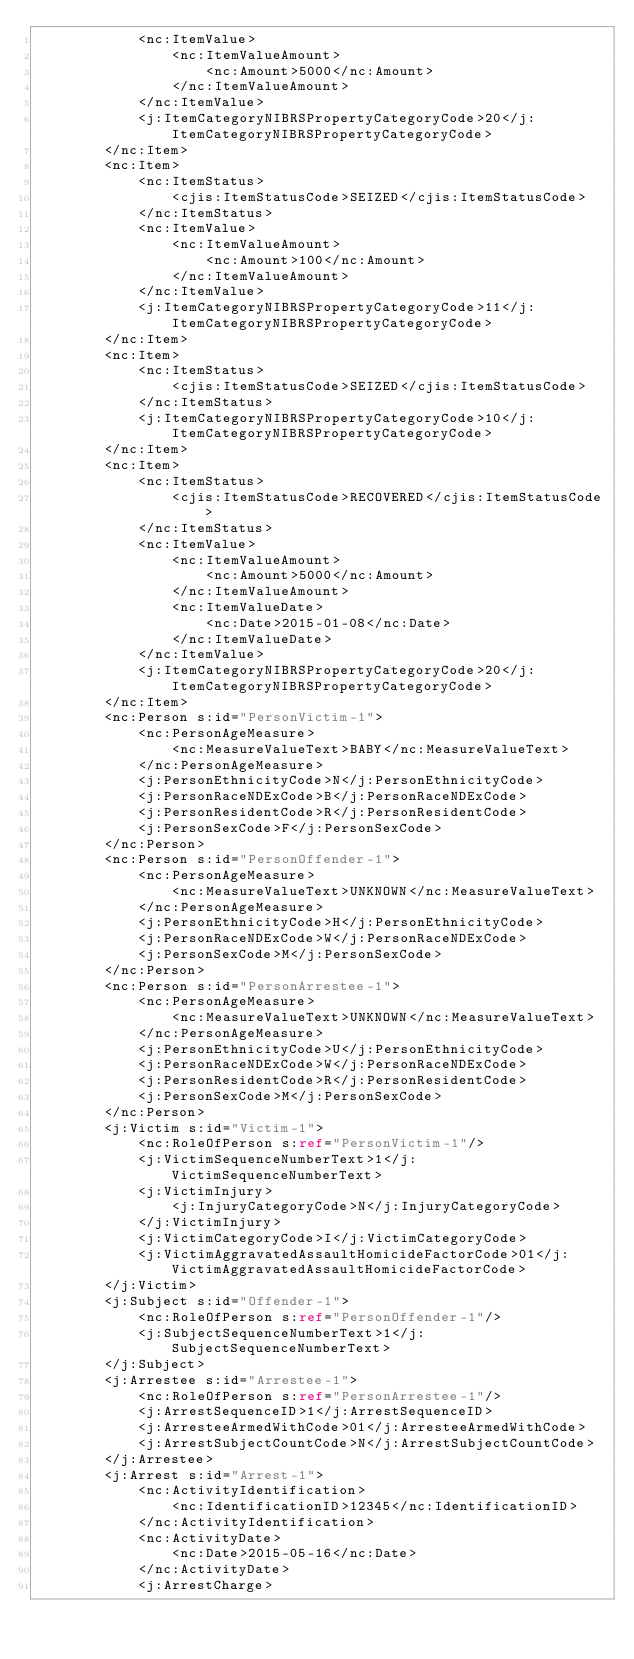Convert code to text. <code><loc_0><loc_0><loc_500><loc_500><_XML_>            <nc:ItemValue>
                <nc:ItemValueAmount>
                    <nc:Amount>5000</nc:Amount>
                </nc:ItemValueAmount>
            </nc:ItemValue>
            <j:ItemCategoryNIBRSPropertyCategoryCode>20</j:ItemCategoryNIBRSPropertyCategoryCode>
        </nc:Item>
        <nc:Item>
            <nc:ItemStatus>
                <cjis:ItemStatusCode>SEIZED</cjis:ItemStatusCode>
            </nc:ItemStatus>
            <nc:ItemValue>
                <nc:ItemValueAmount>
                    <nc:Amount>100</nc:Amount>
                </nc:ItemValueAmount>
            </nc:ItemValue>
            <j:ItemCategoryNIBRSPropertyCategoryCode>11</j:ItemCategoryNIBRSPropertyCategoryCode>
        </nc:Item>
        <nc:Item>
            <nc:ItemStatus>
                <cjis:ItemStatusCode>SEIZED</cjis:ItemStatusCode>
            </nc:ItemStatus>
            <j:ItemCategoryNIBRSPropertyCategoryCode>10</j:ItemCategoryNIBRSPropertyCategoryCode>
        </nc:Item>
        <nc:Item>
            <nc:ItemStatus>
                <cjis:ItemStatusCode>RECOVERED</cjis:ItemStatusCode>
            </nc:ItemStatus>
            <nc:ItemValue>
                <nc:ItemValueAmount>
                    <nc:Amount>5000</nc:Amount>
                </nc:ItemValueAmount>
                <nc:ItemValueDate>
                    <nc:Date>2015-01-08</nc:Date>
                </nc:ItemValueDate>
            </nc:ItemValue>
            <j:ItemCategoryNIBRSPropertyCategoryCode>20</j:ItemCategoryNIBRSPropertyCategoryCode>
        </nc:Item>
        <nc:Person s:id="PersonVictim-1">
            <nc:PersonAgeMeasure>
                <nc:MeasureValueText>BABY</nc:MeasureValueText>
            </nc:PersonAgeMeasure>
            <j:PersonEthnicityCode>N</j:PersonEthnicityCode>
            <j:PersonRaceNDExCode>B</j:PersonRaceNDExCode>
            <j:PersonResidentCode>R</j:PersonResidentCode>
            <j:PersonSexCode>F</j:PersonSexCode>
        </nc:Person>
        <nc:Person s:id="PersonOffender-1">
            <nc:PersonAgeMeasure>
                <nc:MeasureValueText>UNKNOWN</nc:MeasureValueText>
            </nc:PersonAgeMeasure>
            <j:PersonEthnicityCode>H</j:PersonEthnicityCode>
            <j:PersonRaceNDExCode>W</j:PersonRaceNDExCode>
            <j:PersonSexCode>M</j:PersonSexCode>
        </nc:Person>
        <nc:Person s:id="PersonArrestee-1">
            <nc:PersonAgeMeasure>
                <nc:MeasureValueText>UNKNOWN</nc:MeasureValueText>
            </nc:PersonAgeMeasure>
            <j:PersonEthnicityCode>U</j:PersonEthnicityCode>
            <j:PersonRaceNDExCode>W</j:PersonRaceNDExCode>
            <j:PersonResidentCode>R</j:PersonResidentCode>
            <j:PersonSexCode>M</j:PersonSexCode>
        </nc:Person>
        <j:Victim s:id="Victim-1">
            <nc:RoleOfPerson s:ref="PersonVictim-1"/>
            <j:VictimSequenceNumberText>1</j:VictimSequenceNumberText>
            <j:VictimInjury>
                <j:InjuryCategoryCode>N</j:InjuryCategoryCode>
            </j:VictimInjury>
            <j:VictimCategoryCode>I</j:VictimCategoryCode>
            <j:VictimAggravatedAssaultHomicideFactorCode>01</j:VictimAggravatedAssaultHomicideFactorCode>
        </j:Victim>
        <j:Subject s:id="Offender-1">
            <nc:RoleOfPerson s:ref="PersonOffender-1"/>
            <j:SubjectSequenceNumberText>1</j:SubjectSequenceNumberText>
        </j:Subject>
        <j:Arrestee s:id="Arrestee-1">
            <nc:RoleOfPerson s:ref="PersonArrestee-1"/>
            <j:ArrestSequenceID>1</j:ArrestSequenceID>
            <j:ArresteeArmedWithCode>01</j:ArresteeArmedWithCode>
            <j:ArrestSubjectCountCode>N</j:ArrestSubjectCountCode>
        </j:Arrestee>
        <j:Arrest s:id="Arrest-1">
            <nc:ActivityIdentification>
                <nc:IdentificationID>12345</nc:IdentificationID>
            </nc:ActivityIdentification>
            <nc:ActivityDate>
                <nc:Date>2015-05-16</nc:Date>
            </nc:ActivityDate>
            <j:ArrestCharge></code> 